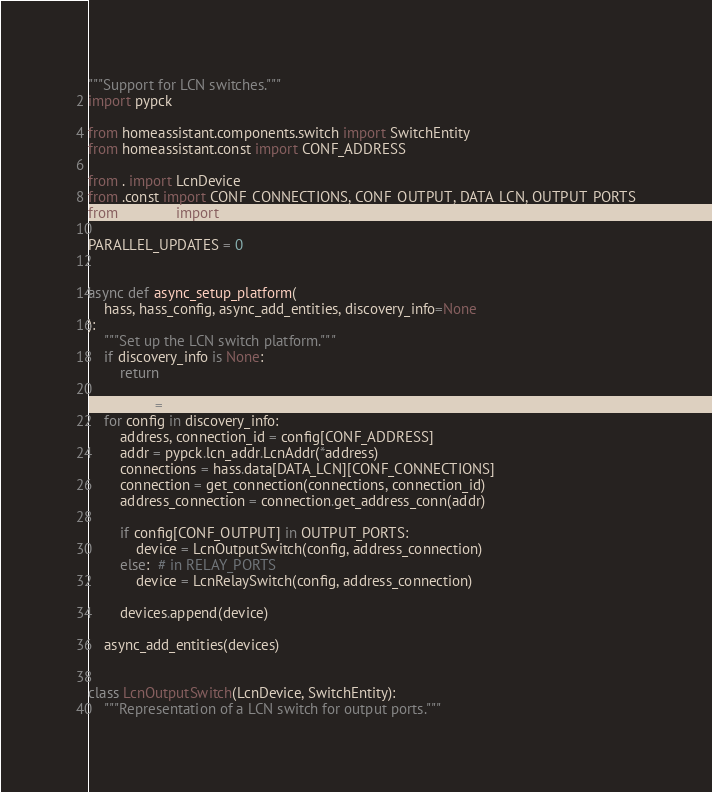Convert code to text. <code><loc_0><loc_0><loc_500><loc_500><_Python_>"""Support for LCN switches."""
import pypck

from homeassistant.components.switch import SwitchEntity
from homeassistant.const import CONF_ADDRESS

from . import LcnDevice
from .const import CONF_CONNECTIONS, CONF_OUTPUT, DATA_LCN, OUTPUT_PORTS
from .helpers import get_connection

PARALLEL_UPDATES = 0


async def async_setup_platform(
    hass, hass_config, async_add_entities, discovery_info=None
):
    """Set up the LCN switch platform."""
    if discovery_info is None:
        return

    devices = []
    for config in discovery_info:
        address, connection_id = config[CONF_ADDRESS]
        addr = pypck.lcn_addr.LcnAddr(*address)
        connections = hass.data[DATA_LCN][CONF_CONNECTIONS]
        connection = get_connection(connections, connection_id)
        address_connection = connection.get_address_conn(addr)

        if config[CONF_OUTPUT] in OUTPUT_PORTS:
            device = LcnOutputSwitch(config, address_connection)
        else:  # in RELAY_PORTS
            device = LcnRelaySwitch(config, address_connection)

        devices.append(device)

    async_add_entities(devices)


class LcnOutputSwitch(LcnDevice, SwitchEntity):
    """Representation of a LCN switch for output ports."""
</code> 